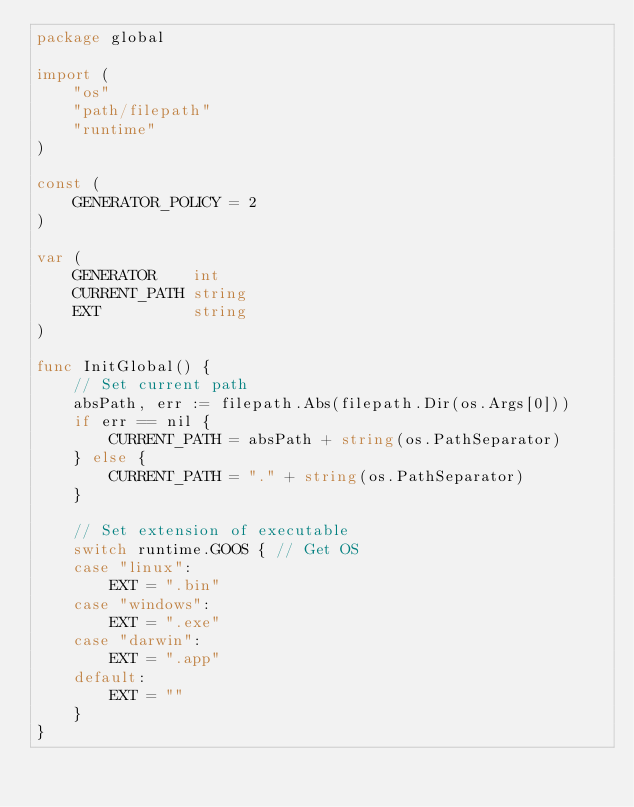<code> <loc_0><loc_0><loc_500><loc_500><_Go_>package global

import (
	"os"
	"path/filepath"
	"runtime"
)

const (
	GENERATOR_POLICY = 2
)

var (
	GENERATOR    int
	CURRENT_PATH string
	EXT          string
)

func InitGlobal() {
	// Set current path
	absPath, err := filepath.Abs(filepath.Dir(os.Args[0]))
	if err == nil {
		CURRENT_PATH = absPath + string(os.PathSeparator)
	} else {
		CURRENT_PATH = "." + string(os.PathSeparator)
	}

	// Set extension of executable
	switch runtime.GOOS { // Get OS
	case "linux":
		EXT = ".bin"
	case "windows":
		EXT = ".exe"
	case "darwin":
		EXT = ".app"
	default:
		EXT = ""
	}
}
</code> 